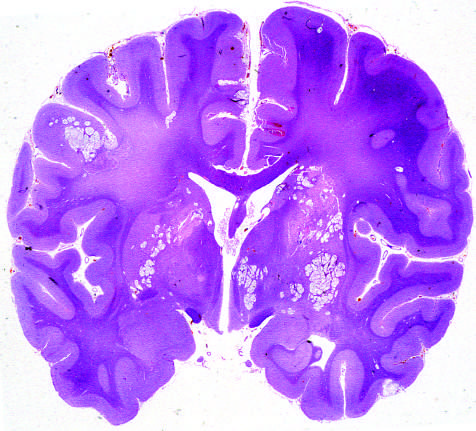s histopathologic features of condyloma acuminatum associated with the spread of organisms in the perivascular spaces?
Answer the question using a single word or phrase. No 